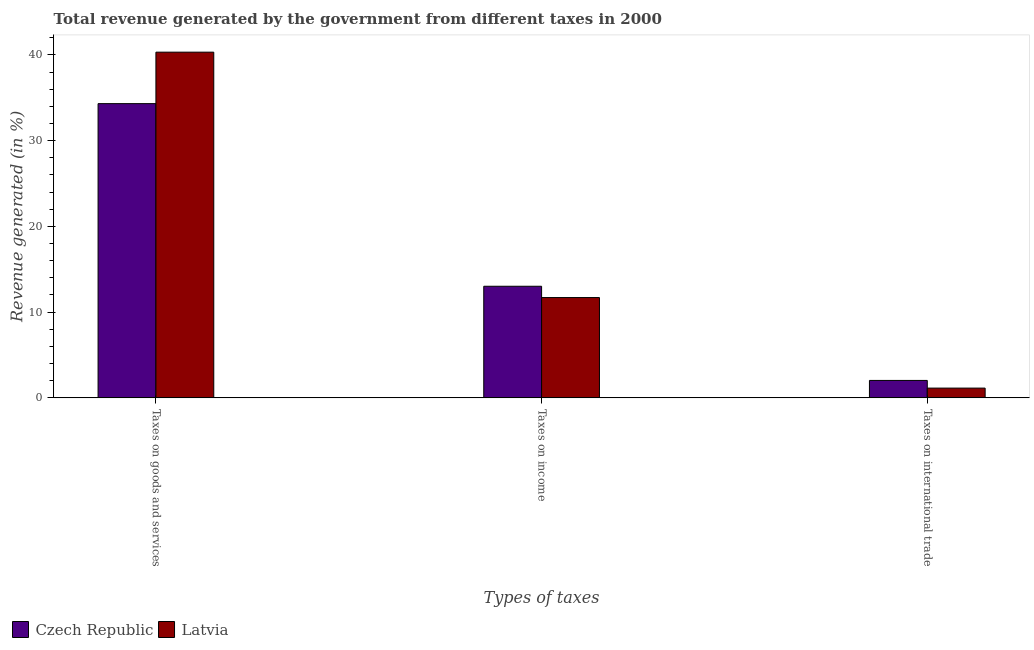How many different coloured bars are there?
Keep it short and to the point. 2. How many groups of bars are there?
Your answer should be compact. 3. Are the number of bars on each tick of the X-axis equal?
Provide a short and direct response. Yes. How many bars are there on the 3rd tick from the left?
Make the answer very short. 2. How many bars are there on the 1st tick from the right?
Your response must be concise. 2. What is the label of the 1st group of bars from the left?
Provide a short and direct response. Taxes on goods and services. What is the percentage of revenue generated by tax on international trade in Latvia?
Give a very brief answer. 1.14. Across all countries, what is the maximum percentage of revenue generated by taxes on goods and services?
Your answer should be compact. 40.33. Across all countries, what is the minimum percentage of revenue generated by taxes on goods and services?
Your answer should be compact. 34.32. In which country was the percentage of revenue generated by tax on international trade maximum?
Ensure brevity in your answer.  Czech Republic. In which country was the percentage of revenue generated by taxes on goods and services minimum?
Offer a very short reply. Czech Republic. What is the total percentage of revenue generated by taxes on goods and services in the graph?
Make the answer very short. 74.65. What is the difference between the percentage of revenue generated by tax on international trade in Latvia and that in Czech Republic?
Offer a very short reply. -0.9. What is the difference between the percentage of revenue generated by tax on international trade in Latvia and the percentage of revenue generated by taxes on goods and services in Czech Republic?
Ensure brevity in your answer.  -33.18. What is the average percentage of revenue generated by taxes on goods and services per country?
Your answer should be very brief. 37.32. What is the difference between the percentage of revenue generated by taxes on goods and services and percentage of revenue generated by tax on international trade in Czech Republic?
Ensure brevity in your answer.  32.29. What is the ratio of the percentage of revenue generated by tax on international trade in Czech Republic to that in Latvia?
Ensure brevity in your answer.  1.79. Is the difference between the percentage of revenue generated by taxes on income in Czech Republic and Latvia greater than the difference between the percentage of revenue generated by tax on international trade in Czech Republic and Latvia?
Offer a terse response. Yes. What is the difference between the highest and the second highest percentage of revenue generated by tax on international trade?
Keep it short and to the point. 0.9. What is the difference between the highest and the lowest percentage of revenue generated by taxes on goods and services?
Give a very brief answer. 6. Is the sum of the percentage of revenue generated by taxes on income in Czech Republic and Latvia greater than the maximum percentage of revenue generated by tax on international trade across all countries?
Your response must be concise. Yes. What does the 2nd bar from the left in Taxes on goods and services represents?
Make the answer very short. Latvia. What does the 1st bar from the right in Taxes on international trade represents?
Offer a very short reply. Latvia. Is it the case that in every country, the sum of the percentage of revenue generated by taxes on goods and services and percentage of revenue generated by taxes on income is greater than the percentage of revenue generated by tax on international trade?
Keep it short and to the point. Yes. How many bars are there?
Offer a terse response. 6. What is the difference between two consecutive major ticks on the Y-axis?
Offer a terse response. 10. Does the graph contain grids?
Your response must be concise. No. How many legend labels are there?
Your response must be concise. 2. What is the title of the graph?
Provide a succinct answer. Total revenue generated by the government from different taxes in 2000. Does "Bhutan" appear as one of the legend labels in the graph?
Ensure brevity in your answer.  No. What is the label or title of the X-axis?
Your answer should be compact. Types of taxes. What is the label or title of the Y-axis?
Make the answer very short. Revenue generated (in %). What is the Revenue generated (in %) in Czech Republic in Taxes on goods and services?
Your answer should be compact. 34.32. What is the Revenue generated (in %) of Latvia in Taxes on goods and services?
Your response must be concise. 40.33. What is the Revenue generated (in %) in Czech Republic in Taxes on income?
Ensure brevity in your answer.  13.02. What is the Revenue generated (in %) of Latvia in Taxes on income?
Offer a very short reply. 11.7. What is the Revenue generated (in %) of Czech Republic in Taxes on international trade?
Ensure brevity in your answer.  2.03. What is the Revenue generated (in %) of Latvia in Taxes on international trade?
Offer a very short reply. 1.14. Across all Types of taxes, what is the maximum Revenue generated (in %) of Czech Republic?
Provide a succinct answer. 34.32. Across all Types of taxes, what is the maximum Revenue generated (in %) of Latvia?
Keep it short and to the point. 40.33. Across all Types of taxes, what is the minimum Revenue generated (in %) in Czech Republic?
Keep it short and to the point. 2.03. Across all Types of taxes, what is the minimum Revenue generated (in %) of Latvia?
Provide a succinct answer. 1.14. What is the total Revenue generated (in %) of Czech Republic in the graph?
Give a very brief answer. 49.38. What is the total Revenue generated (in %) of Latvia in the graph?
Your answer should be compact. 53.17. What is the difference between the Revenue generated (in %) in Czech Republic in Taxes on goods and services and that in Taxes on income?
Your response must be concise. 21.3. What is the difference between the Revenue generated (in %) in Latvia in Taxes on goods and services and that in Taxes on income?
Offer a terse response. 28.63. What is the difference between the Revenue generated (in %) of Czech Republic in Taxes on goods and services and that in Taxes on international trade?
Your answer should be very brief. 32.29. What is the difference between the Revenue generated (in %) of Latvia in Taxes on goods and services and that in Taxes on international trade?
Offer a terse response. 39.19. What is the difference between the Revenue generated (in %) of Czech Republic in Taxes on income and that in Taxes on international trade?
Your answer should be very brief. 10.98. What is the difference between the Revenue generated (in %) in Latvia in Taxes on income and that in Taxes on international trade?
Make the answer very short. 10.56. What is the difference between the Revenue generated (in %) of Czech Republic in Taxes on goods and services and the Revenue generated (in %) of Latvia in Taxes on income?
Make the answer very short. 22.62. What is the difference between the Revenue generated (in %) in Czech Republic in Taxes on goods and services and the Revenue generated (in %) in Latvia in Taxes on international trade?
Provide a short and direct response. 33.18. What is the difference between the Revenue generated (in %) in Czech Republic in Taxes on income and the Revenue generated (in %) in Latvia in Taxes on international trade?
Your response must be concise. 11.88. What is the average Revenue generated (in %) of Czech Republic per Types of taxes?
Give a very brief answer. 16.46. What is the average Revenue generated (in %) of Latvia per Types of taxes?
Provide a short and direct response. 17.72. What is the difference between the Revenue generated (in %) in Czech Republic and Revenue generated (in %) in Latvia in Taxes on goods and services?
Your answer should be compact. -6. What is the difference between the Revenue generated (in %) in Czech Republic and Revenue generated (in %) in Latvia in Taxes on income?
Give a very brief answer. 1.32. What is the difference between the Revenue generated (in %) of Czech Republic and Revenue generated (in %) of Latvia in Taxes on international trade?
Your answer should be very brief. 0.9. What is the ratio of the Revenue generated (in %) of Czech Republic in Taxes on goods and services to that in Taxes on income?
Your response must be concise. 2.64. What is the ratio of the Revenue generated (in %) in Latvia in Taxes on goods and services to that in Taxes on income?
Your answer should be compact. 3.45. What is the ratio of the Revenue generated (in %) in Czech Republic in Taxes on goods and services to that in Taxes on international trade?
Offer a terse response. 16.87. What is the ratio of the Revenue generated (in %) in Latvia in Taxes on goods and services to that in Taxes on international trade?
Offer a very short reply. 35.39. What is the ratio of the Revenue generated (in %) in Czech Republic in Taxes on income to that in Taxes on international trade?
Ensure brevity in your answer.  6.4. What is the ratio of the Revenue generated (in %) in Latvia in Taxes on income to that in Taxes on international trade?
Make the answer very short. 10.27. What is the difference between the highest and the second highest Revenue generated (in %) of Czech Republic?
Your answer should be very brief. 21.3. What is the difference between the highest and the second highest Revenue generated (in %) in Latvia?
Provide a short and direct response. 28.63. What is the difference between the highest and the lowest Revenue generated (in %) of Czech Republic?
Provide a succinct answer. 32.29. What is the difference between the highest and the lowest Revenue generated (in %) in Latvia?
Make the answer very short. 39.19. 